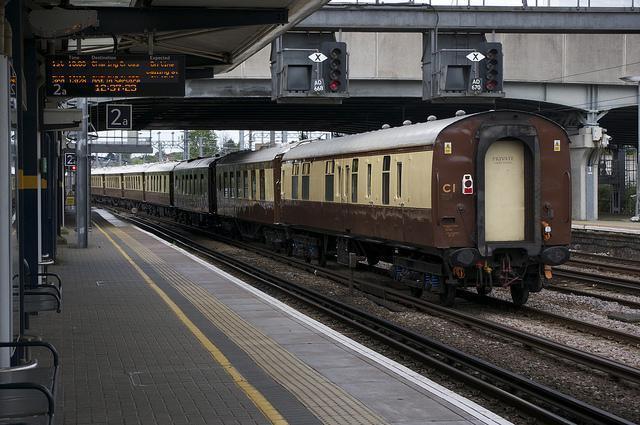How many people on horses?
Give a very brief answer. 0. 